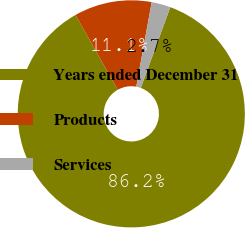<chart> <loc_0><loc_0><loc_500><loc_500><pie_chart><fcel>Years ended December 31<fcel>Products<fcel>Services<nl><fcel>86.24%<fcel>11.05%<fcel>2.7%<nl></chart> 